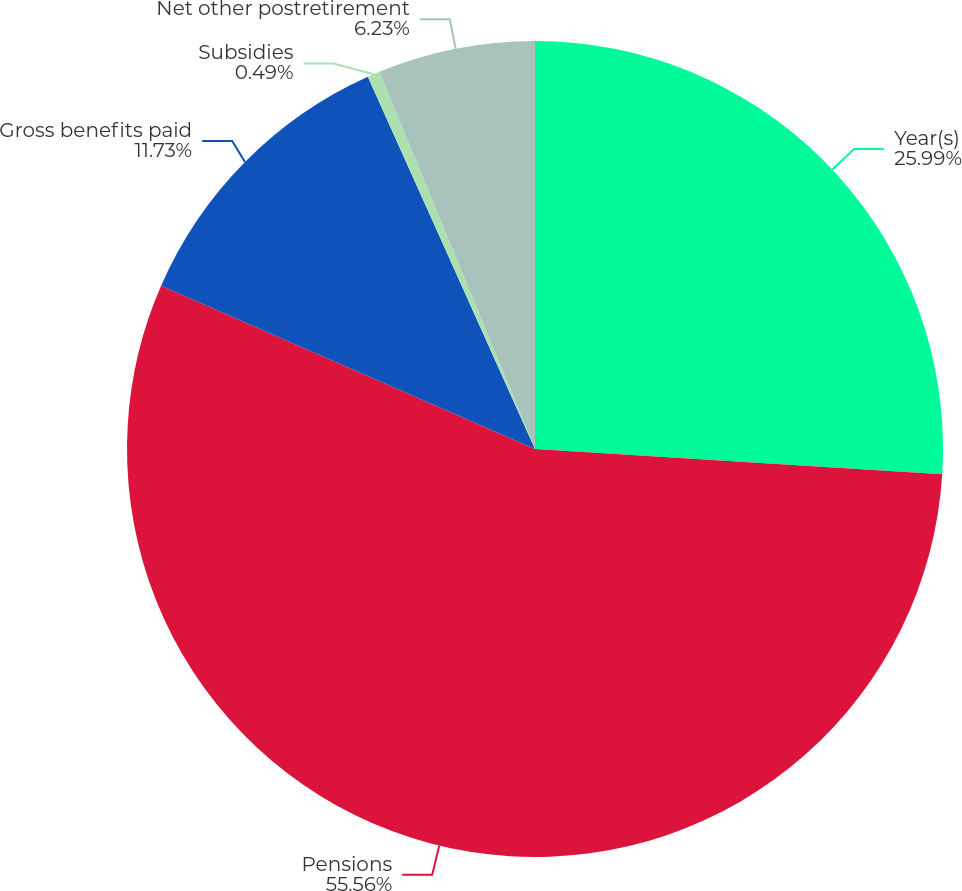<chart> <loc_0><loc_0><loc_500><loc_500><pie_chart><fcel>Year(s)<fcel>Pensions<fcel>Gross benefits paid<fcel>Subsidies<fcel>Net other postretirement<nl><fcel>25.99%<fcel>55.57%<fcel>11.73%<fcel>0.49%<fcel>6.23%<nl></chart> 